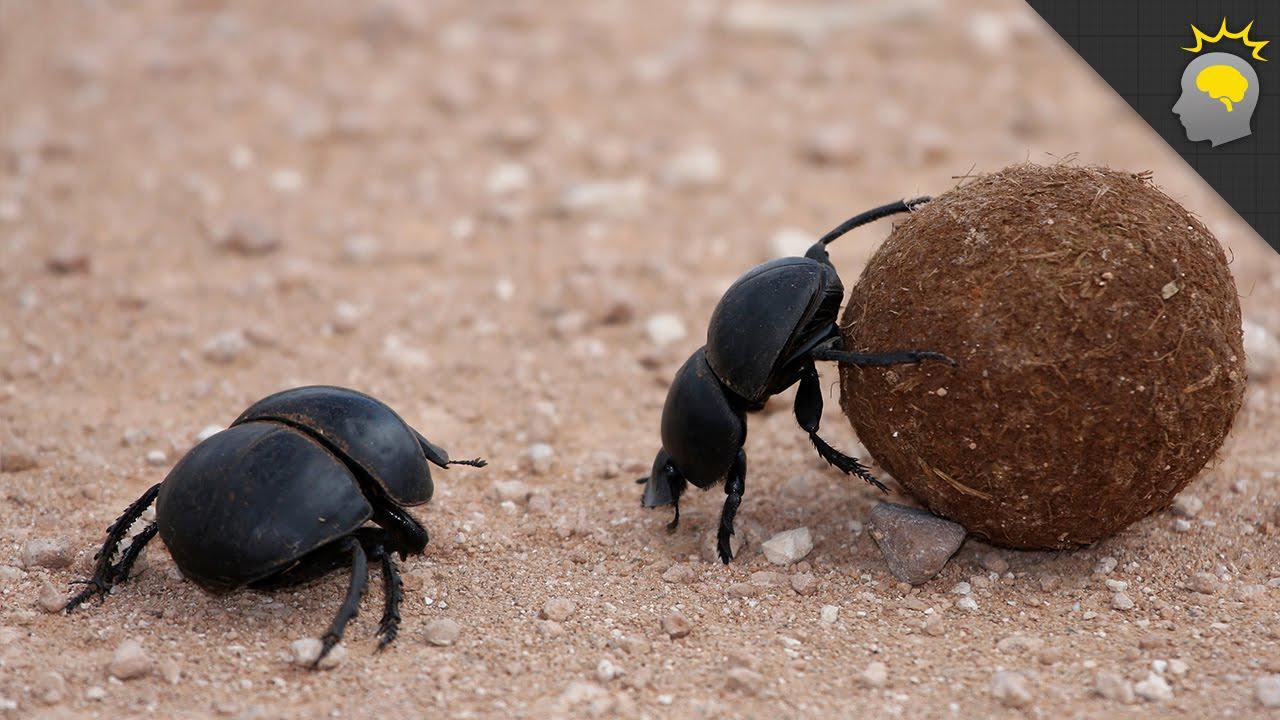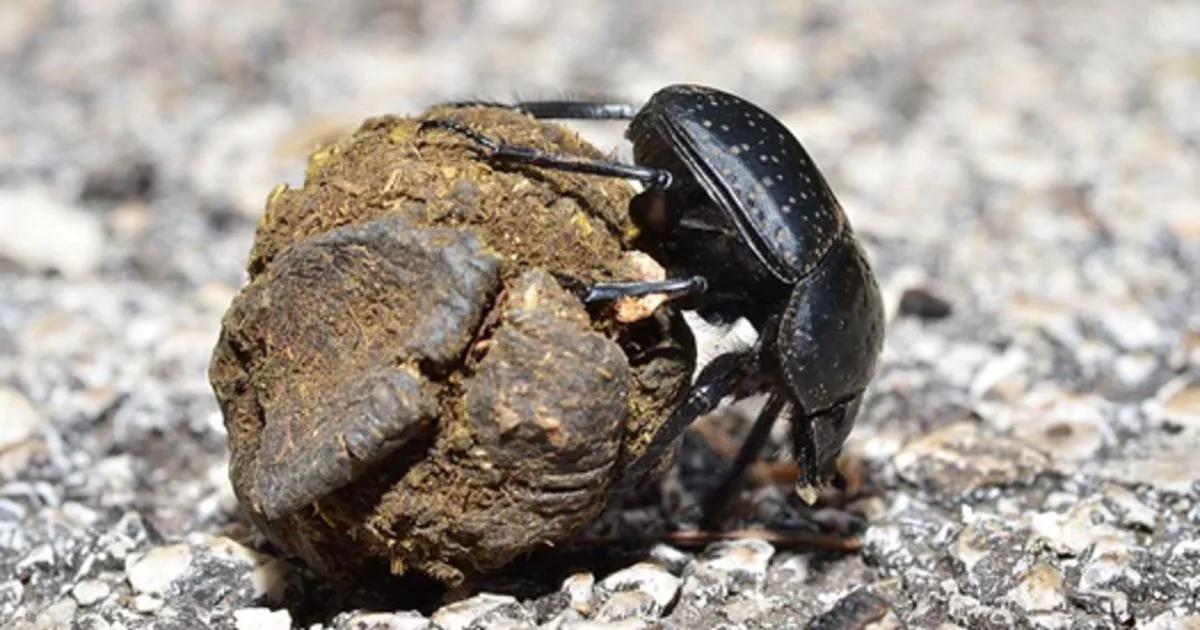The first image is the image on the left, the second image is the image on the right. For the images displayed, is the sentence "Every image has a single beetle and a single dungball." factually correct? Answer yes or no. No. The first image is the image on the left, the second image is the image on the right. Evaluate the accuracy of this statement regarding the images: "One image contains two beetles and a single brown ball.". Is it true? Answer yes or no. Yes. 